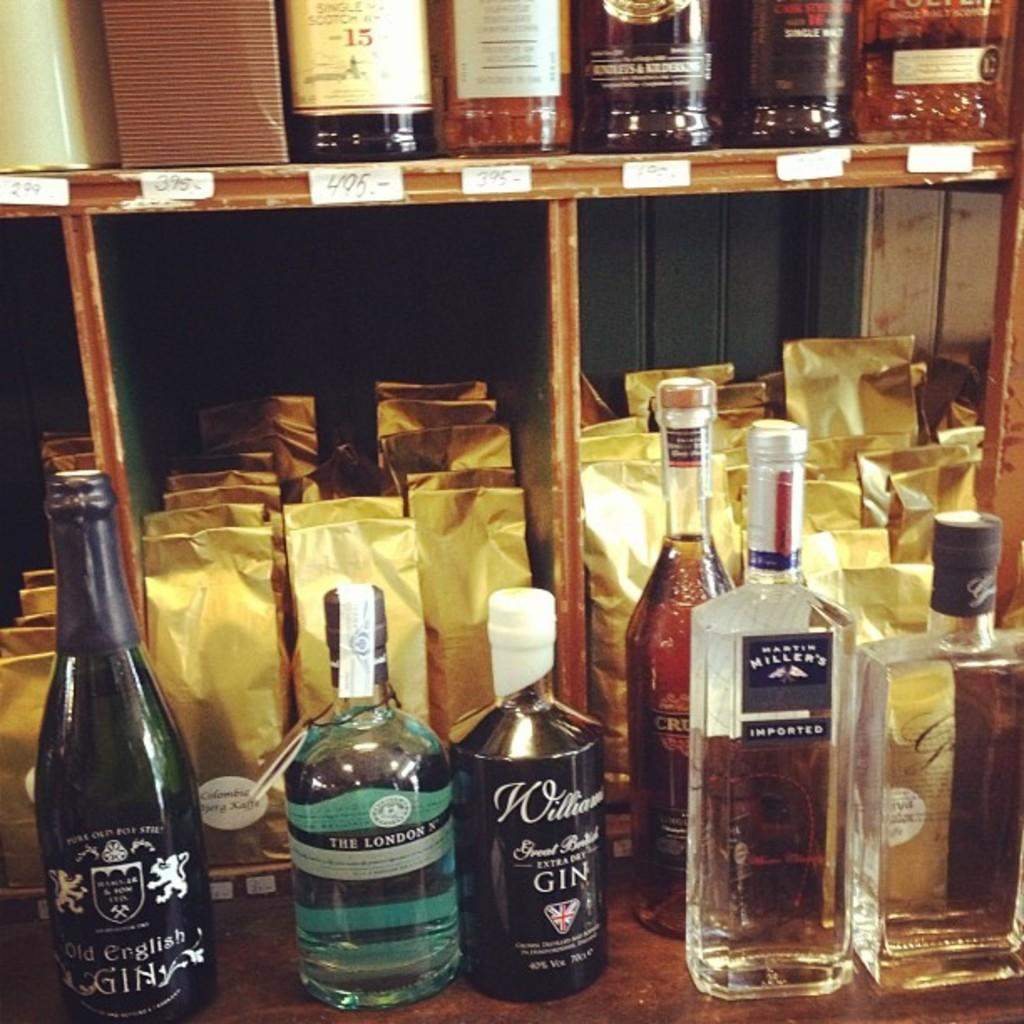What is the main subject of the image? The main subject of the image is a group of bottles. What is inside the bottles? The bottles are filled with a drink. How are the bottles arranged in the image? Some bottles are on the top of the group, while others are in the center. What else can be seen in the center of the group? There are packets in the center of the group. What direction is the marble moving in the image? There is no marble present in the image. What type of wall can be seen in the background of the image? The image does not show a wall in the background. 